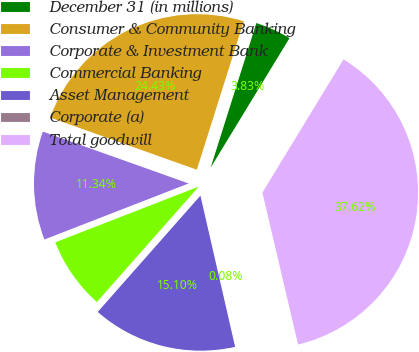Convert chart. <chart><loc_0><loc_0><loc_500><loc_500><pie_chart><fcel>December 31 (in millions)<fcel>Consumer & Community Banking<fcel>Corporate & Investment Bank<fcel>Commercial Banking<fcel>Asset Management<fcel>Corporate (a)<fcel>Total goodwill<nl><fcel>3.83%<fcel>24.43%<fcel>11.34%<fcel>7.59%<fcel>15.1%<fcel>0.08%<fcel>37.62%<nl></chart> 